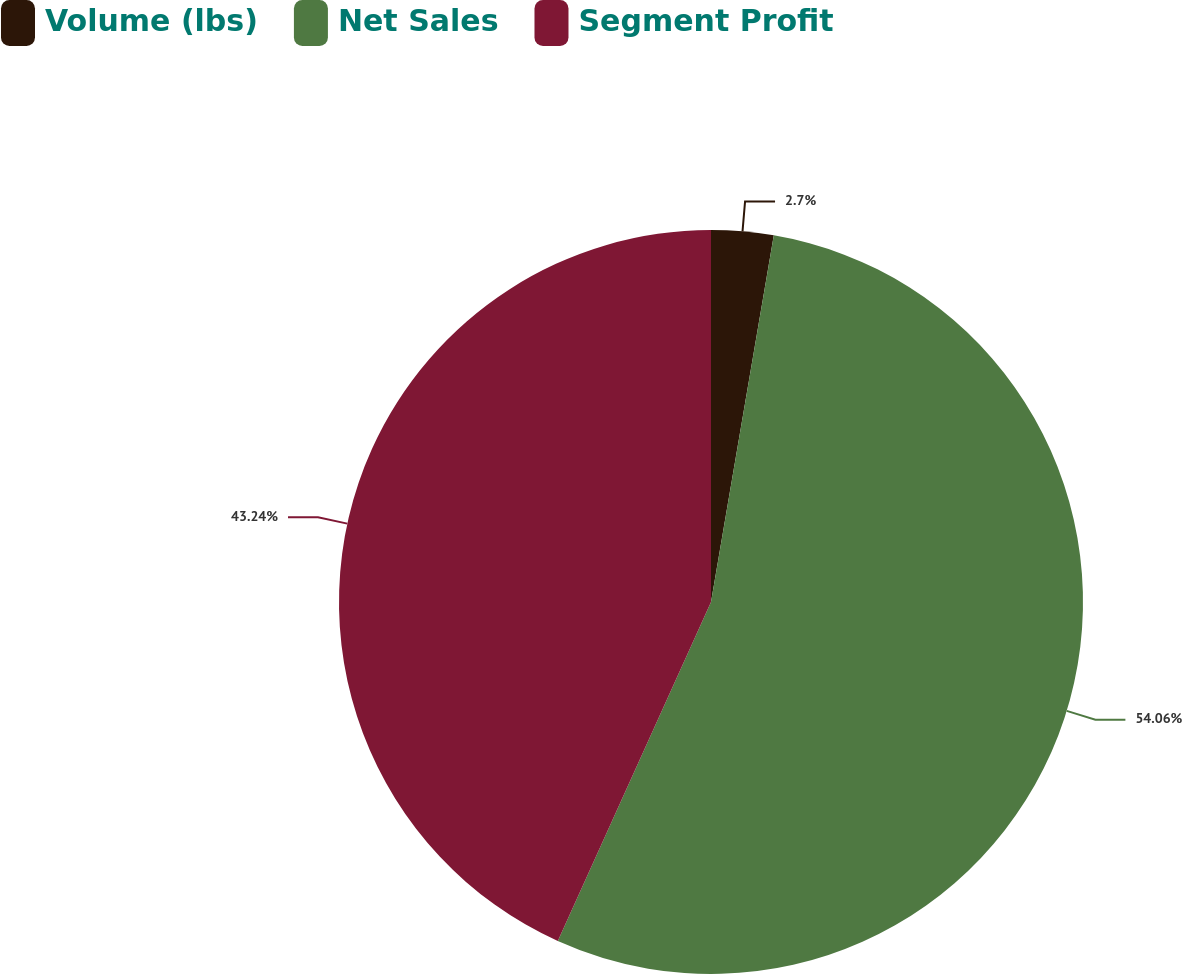<chart> <loc_0><loc_0><loc_500><loc_500><pie_chart><fcel>Volume (lbs)<fcel>Net Sales<fcel>Segment Profit<nl><fcel>2.7%<fcel>54.05%<fcel>43.24%<nl></chart> 